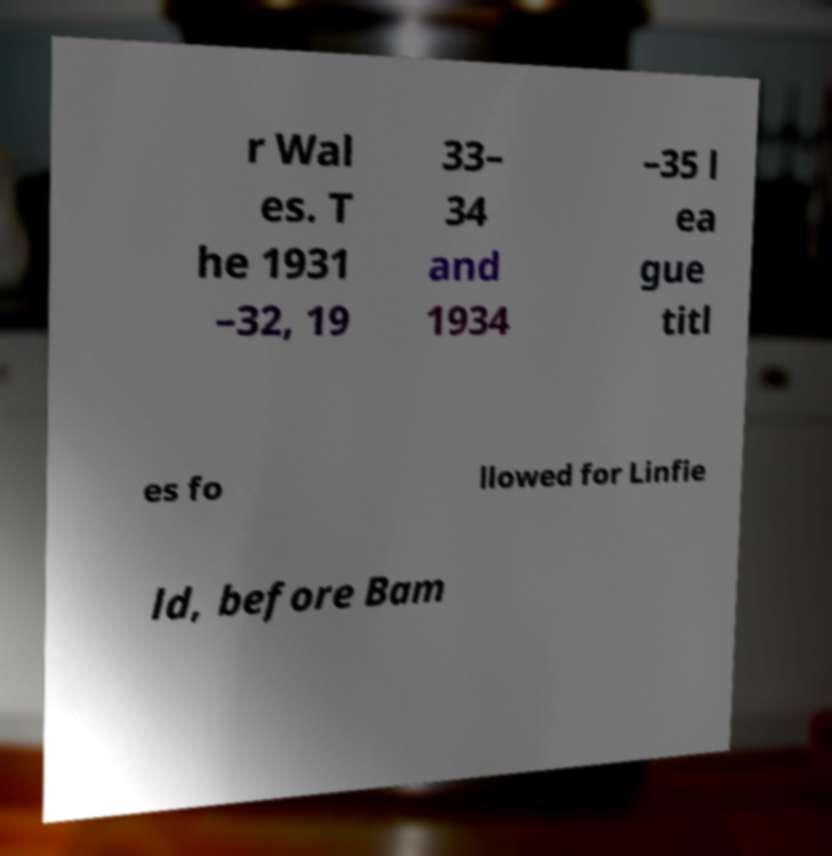I need the written content from this picture converted into text. Can you do that? r Wal es. T he 1931 –32, 19 33– 34 and 1934 –35 l ea gue titl es fo llowed for Linfie ld, before Bam 